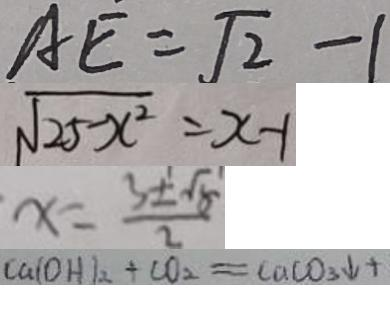<formula> <loc_0><loc_0><loc_500><loc_500>A E = \sqrt { 2 } - 1 
 \sqrt { 2 5 - x ^ { 2 } } = x - 1 
 x = \frac { 3 \pm \sqrt { 5 } } { 2 } 
 C a ( O H ) _ { 2 } + C O _ { 2 } = C a C O _ { 3 } \downarrow +</formula> 